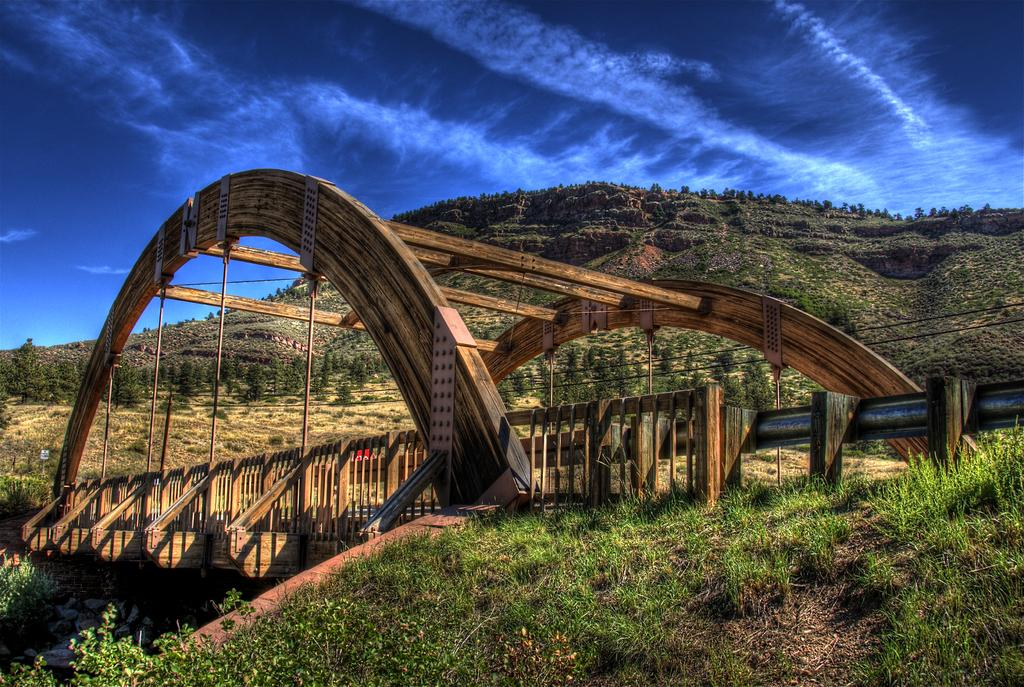What type of structure can be seen in the image? There is a bridge in the image. What natural features are present in the image? There are hills in the image. What material is present in the image? Stones are present in the image. What architectural feature can be seen in the bridge? There is an arch in the image. What is visible at the top of the image? The sky is visible at the top of the image. What type of vegetation is present at the bottom of the image? The ground is covered with grass and plants at the bottom of the image. What type of treatment is being administered to the bridge in the image? There is no treatment being administered to the bridge in the image; it is a static structure. Can you provide an example of motion in the image? There is no motion depicted in the image; it is a still scene. 